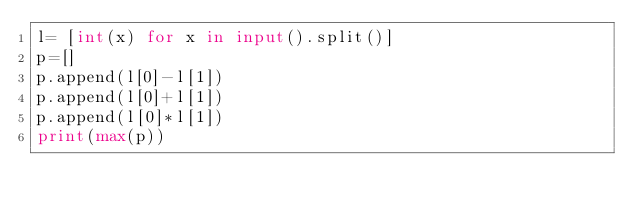Convert code to text. <code><loc_0><loc_0><loc_500><loc_500><_Python_>l= [int(x) for x in input().split()]
p=[]
p.append(l[0]-l[1])
p.append(l[0]+l[1])
p.append(l[0]*l[1])
print(max(p))
</code> 